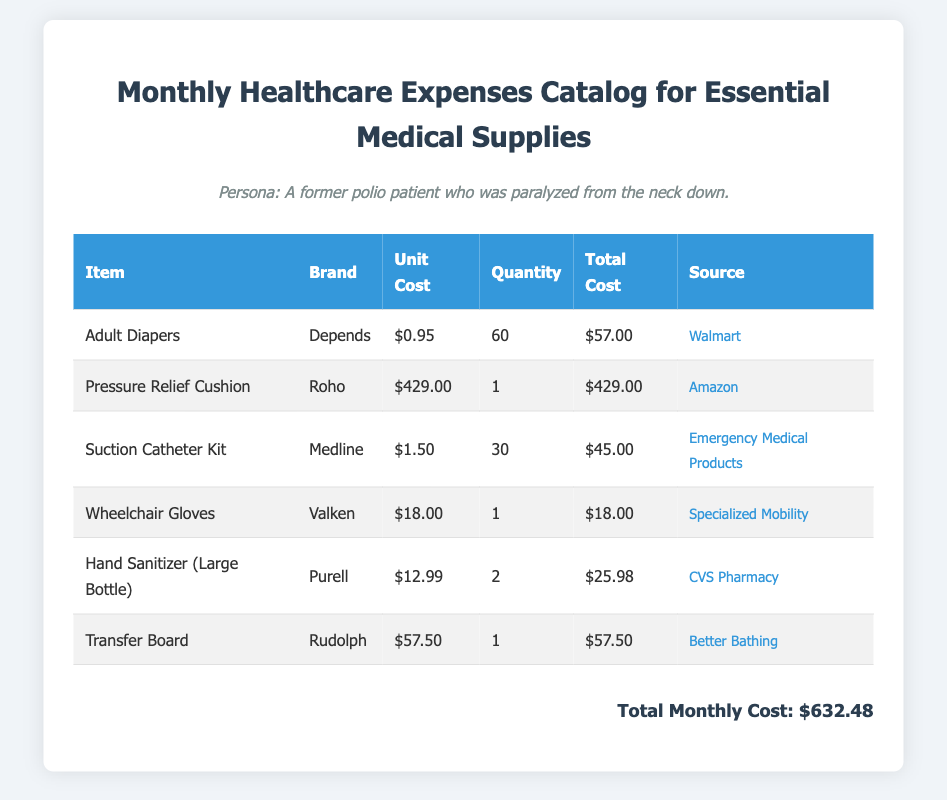What is the unit cost of Adult Diapers? The unit cost of Adult Diapers is listed under the column for unit costs in the table.
Answer: $0.95 How many Pressure Relief Cushions are included in the catalog? The quantity of Pressure Relief Cushions can be found in the quantity column of the table.
Answer: 1 What is the total cost for Suction Catheter Kits? The total cost for Suction Catheter Kits is found in the total cost column of the table.
Answer: $45.00 Which brand is associated with Transfer Board? The brand can be identified in the brand column next to Transfer Board in the table.
Answer: Rudolph What is the total monthly cost for all items? The total monthly cost is summarized at the bottom of the document.
Answer: $632.48 How many units of Hand Sanitizer are purchased? The quantity of Hand Sanitizer is stated in the quantity column of the table.
Answer: 2 Which item has the highest unit cost? To determine this, compare the unit costs of all items in the catalog; the highest one is found in the unit cost column.
Answer: Pressure Relief Cushion What is the source for Wheelchair Gloves? The source for Wheelchair Gloves is presented in the source column of the table.
Answer: Specialized Mobility What is the brand of Adult Diapers? The brand can be located in the brand column next to Adult Diapers in the table.
Answer: Depends 